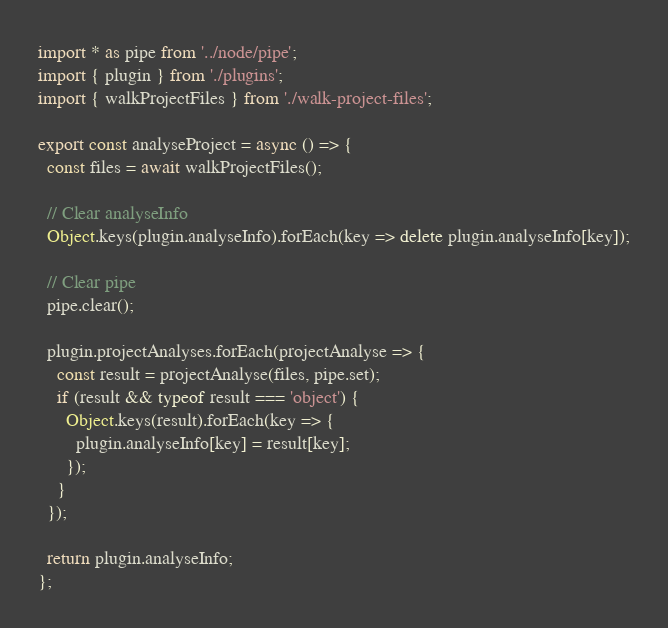Convert code to text. <code><loc_0><loc_0><loc_500><loc_500><_TypeScript_>import * as pipe from '../node/pipe';
import { plugin } from './plugins';
import { walkProjectFiles } from './walk-project-files';

export const analyseProject = async () => {
  const files = await walkProjectFiles();

  // Clear analyseInfo
  Object.keys(plugin.analyseInfo).forEach(key => delete plugin.analyseInfo[key]);

  // Clear pipe
  pipe.clear();

  plugin.projectAnalyses.forEach(projectAnalyse => {
    const result = projectAnalyse(files, pipe.set);
    if (result && typeof result === 'object') {
      Object.keys(result).forEach(key => {
        plugin.analyseInfo[key] = result[key];
      });
    }
  });

  return plugin.analyseInfo;
};
</code> 